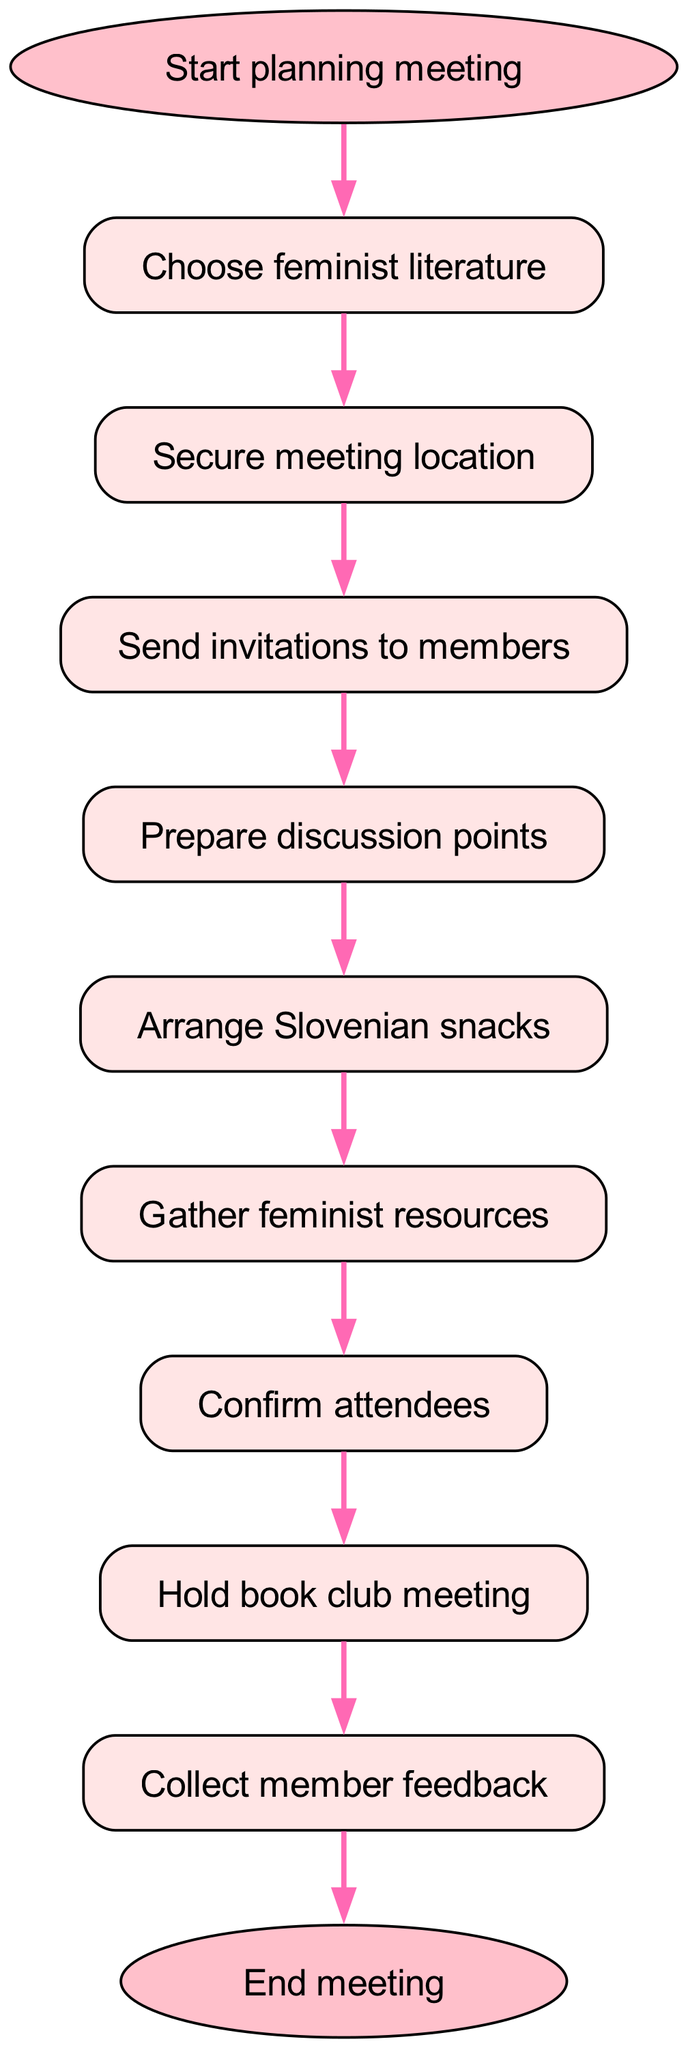What is the first step in planning the meeting? The diagram shows that the first step is "Start planning meeting." This is indicated by the "start" node, which is the initial point in the flowchart.
Answer: Start planning meeting How many nodes are there in the diagram? By counting the elements listed, there are a total of 11 nodes in the diagram. Each node represents a step in the flowchart.
Answer: 11 What is the last step of the meeting process? The final step is indicated by the "end" node, which states "End meeting." This shows the conclusion of the entire process.
Answer: End meeting Which step comes after securing the meeting location? According to the flow of the diagram, the step that follows "Secure meeting location" is "Send invitations to members." This is shown by the connection from the "venue" node to the "invite" node.
Answer: Send invitations to members What are the two steps before confirming attendees? The two steps before "Confirm attendees" are "Gather feminist resources" and "Prepare discussion points." This is traced by following the edges back from the "confirm" node to the two preceding nodes.
Answer: Gather feminist resources, Prepare discussion points How many steps involve preparing something? The diagram shows a total of three steps that involve preparing: "Prepare discussion points," "Arrange Slovenian snacks," and "Gather feminist resources." Thus, the answer is deduced by identifying all nodes that involve preparation.
Answer: 3 What is the relationship between sending invitations and preparing discussion points? The diagram shows that "Send invitations to members" comes after "Prepare discussion points." This implies an order where invitations are sent after discussion points have been prepared.
Answer: Send invitations to members comes after preparing discussion points What type of resources are gathered before confirming attendees? The flowchart specifies "Gather feminist resources" as the task prior to "Confirm attendees." This emphasizes the focus on feminist literature and discussions.
Answer: Feminist resources How does feedback fit into the overall meeting process? According to the flowchart, "Collect member feedback" follows the "Hold book club meeting" step, indicating that feedback is gathered after the meeting takes place. This is crucial for assessing the meeting's effectiveness.
Answer: Feedback comes after the meeting 